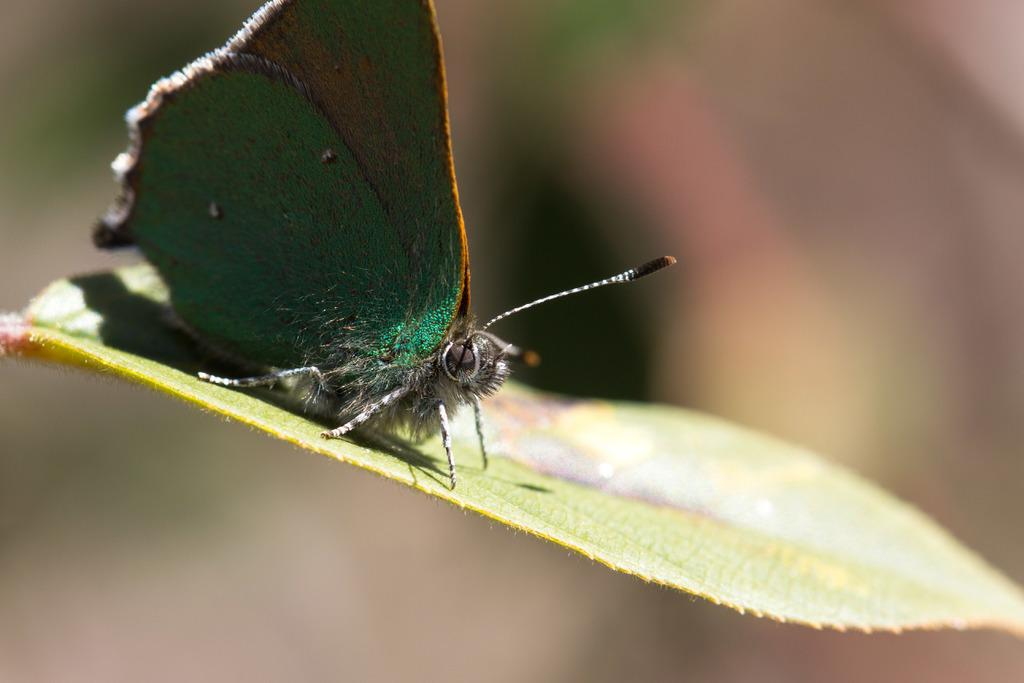What is the main subject of the image? There is a butterfly in the image. Where is the butterfly located? The butterfly is on a leaf. What type of drum is being played by the butterfly in the image? There is no drum present in the image, as it features a butterfly on a leaf. What song is the butterfly singing in the image? Butterflies do not sing songs, so there is no song being sung by the butterfly in the image. 